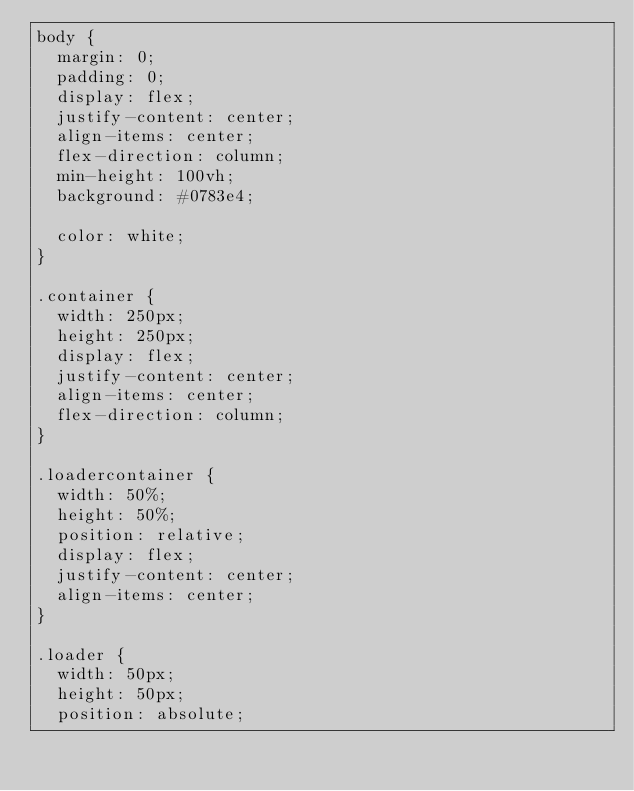<code> <loc_0><loc_0><loc_500><loc_500><_CSS_>body {
  margin: 0;
  padding: 0;
  display: flex;
  justify-content: center;
  align-items: center;
  flex-direction: column;
  min-height: 100vh;
  background: #0783e4;

  color: white;
}

.container {
  width: 250px;
  height: 250px;
  display: flex;
  justify-content: center;
  align-items: center;
  flex-direction: column;
}

.loadercontainer {
  width: 50%;
  height: 50%;
  position: relative;
  display: flex;
  justify-content: center;
  align-items: center;
}

.loader {
  width: 50px;
  height: 50px;
  position: absolute;</code> 